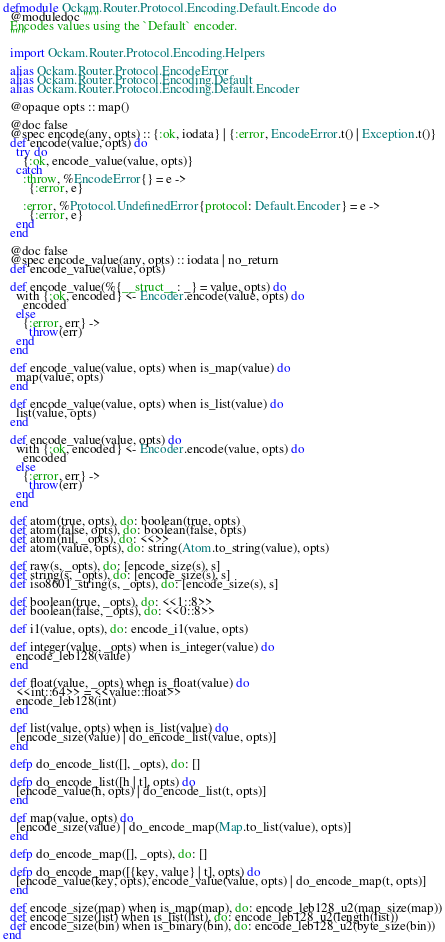<code> <loc_0><loc_0><loc_500><loc_500><_Elixir_>defmodule Ockam.Router.Protocol.Encoding.Default.Encode do
  @moduledoc """
  Encodes values using the `Default` encoder.
  """

  import Ockam.Router.Protocol.Encoding.Helpers

  alias Ockam.Router.Protocol.EncodeError
  alias Ockam.Router.Protocol.Encoding.Default
  alias Ockam.Router.Protocol.Encoding.Default.Encoder

  @opaque opts :: map()

  @doc false
  @spec encode(any, opts) :: {:ok, iodata} | {:error, EncodeError.t() | Exception.t()}
  def encode(value, opts) do
    try do
      {:ok, encode_value(value, opts)}
    catch
      :throw, %EncodeError{} = e ->
        {:error, e}

      :error, %Protocol.UndefinedError{protocol: Default.Encoder} = e ->
        {:error, e}
    end
  end

  @doc false
  @spec encode_value(any, opts) :: iodata | no_return
  def encode_value(value, opts)

  def encode_value(%{__struct__: _} = value, opts) do
    with {:ok, encoded} <- Encoder.encode(value, opts) do
      encoded
    else
      {:error, err} ->
        throw(err)
    end
  end

  def encode_value(value, opts) when is_map(value) do
    map(value, opts)
  end

  def encode_value(value, opts) when is_list(value) do
    list(value, opts)
  end

  def encode_value(value, opts) do
    with {:ok, encoded} <- Encoder.encode(value, opts) do
      encoded
    else
      {:error, err} ->
        throw(err)
    end
  end

  def atom(true, opts), do: boolean(true, opts)
  def atom(false, opts), do: boolean(false, opts)
  def atom(nil, _opts), do: <<>>
  def atom(value, opts), do: string(Atom.to_string(value), opts)

  def raw(s, _opts), do: [encode_size(s), s]
  def string(s, _opts), do: [encode_size(s), s]
  def iso8601_string(s, _opts), do: [encode_size(s), s]

  def boolean(true, _opts), do: <<1::8>>
  def boolean(false, _opts), do: <<0::8>>

  def i1(value, opts), do: encode_i1(value, opts)

  def integer(value, _opts) when is_integer(value) do
    encode_leb128(value)
  end

  def float(value, _opts) when is_float(value) do
    <<int::64>> = <<value::float>>
    encode_leb128(int)
  end

  def list(value, opts) when is_list(value) do
    [encode_size(value) | do_encode_list(value, opts)]
  end

  defp do_encode_list([], _opts), do: []

  defp do_encode_list([h | t], opts) do
    [encode_value(h, opts) | do_encode_list(t, opts)]
  end

  def map(value, opts) do
    [encode_size(value) | do_encode_map(Map.to_list(value), opts)]
  end

  defp do_encode_map([], _opts), do: []

  defp do_encode_map([{key, value} | t], opts) do
    [encode_value(key, opts), encode_value(value, opts) | do_encode_map(t, opts)]
  end

  def encode_size(map) when is_map(map), do: encode_leb128_u2(map_size(map))
  def encode_size(list) when is_list(list), do: encode_leb128_u2(length(list))
  def encode_size(bin) when is_binary(bin), do: encode_leb128_u2(byte_size(bin))
end
</code> 